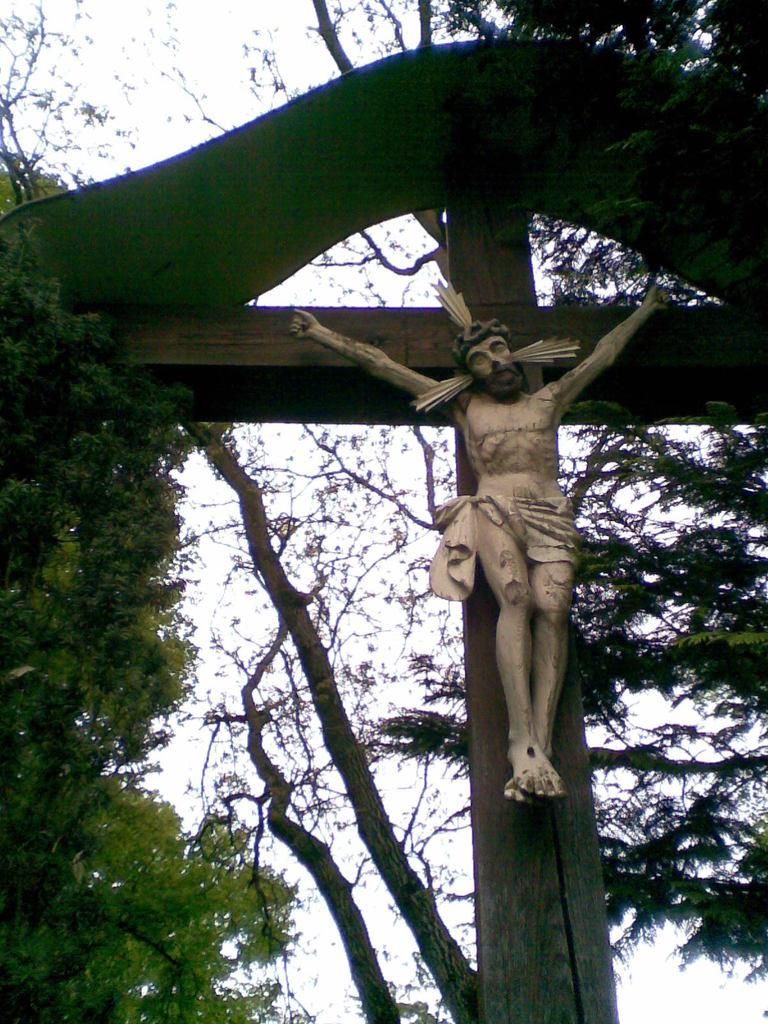What religious symbol is present in the image? There is a cross in the image. What other object can be seen in the image? There is a statue in the image. What type of vegetation is visible in the image? There are trees in the image. What is visible in the background of the image? The sky is visible in the background of the image. What thought process is the statue going through in the image? The statue is not capable of thinking or having a thought process, as it is an inanimate object. 